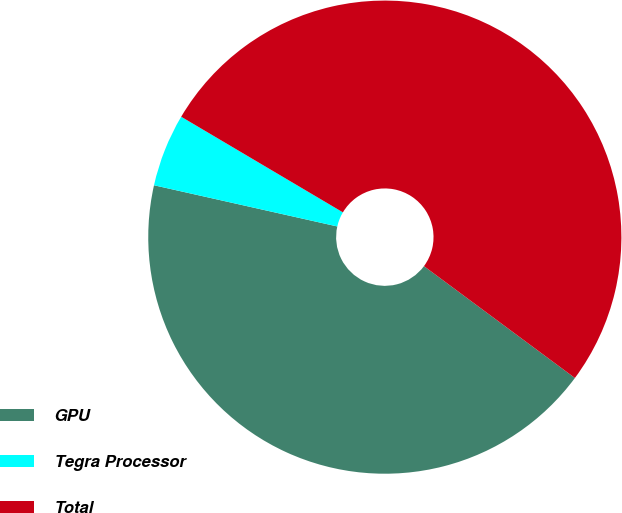<chart> <loc_0><loc_0><loc_500><loc_500><pie_chart><fcel>GPU<fcel>Tegra Processor<fcel>Total<nl><fcel>43.37%<fcel>4.98%<fcel>51.65%<nl></chart> 